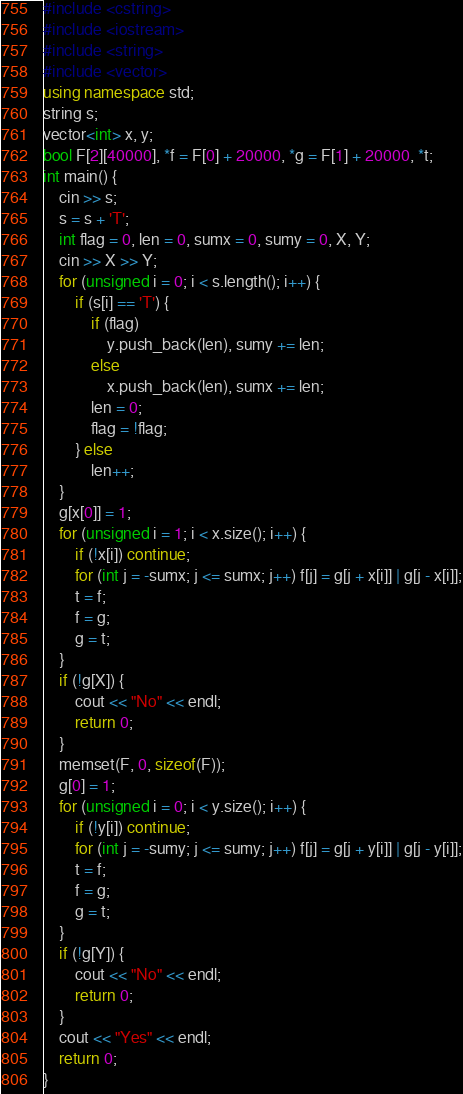Convert code to text. <code><loc_0><loc_0><loc_500><loc_500><_C++_>#include <cstring>
#include <iostream>
#include <string>
#include <vector>
using namespace std;
string s;
vector<int> x, y;
bool F[2][40000], *f = F[0] + 20000, *g = F[1] + 20000, *t;
int main() {
    cin >> s;
    s = s + 'T';
    int flag = 0, len = 0, sumx = 0, sumy = 0, X, Y;
    cin >> X >> Y;
    for (unsigned i = 0; i < s.length(); i++) {
        if (s[i] == 'T') {
            if (flag)
                y.push_back(len), sumy += len;
            else
                x.push_back(len), sumx += len;
            len = 0;
            flag = !flag;
        } else
            len++;
    }
    g[x[0]] = 1;
    for (unsigned i = 1; i < x.size(); i++) {
        if (!x[i]) continue;
        for (int j = -sumx; j <= sumx; j++) f[j] = g[j + x[i]] | g[j - x[i]];
        t = f;
        f = g;
        g = t;
    }
    if (!g[X]) {
        cout << "No" << endl;
        return 0;
    }
    memset(F, 0, sizeof(F));
    g[0] = 1;
    for (unsigned i = 0; i < y.size(); i++) {
        if (!y[i]) continue;
        for (int j = -sumy; j <= sumy; j++) f[j] = g[j + y[i]] | g[j - y[i]];
        t = f;
        f = g;
        g = t;
    }
    if (!g[Y]) {
        cout << "No" << endl;
        return 0;
    }
    cout << "Yes" << endl;
    return 0;
}</code> 